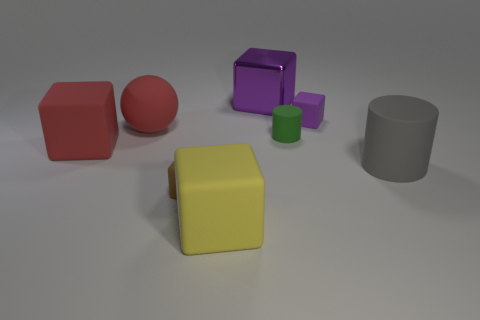Are there any gray objects that have the same material as the large yellow cube?
Offer a very short reply. Yes. There is a small thing left of the big yellow matte thing; is it the same shape as the matte thing that is behind the red ball?
Your answer should be compact. Yes. Are there any big red objects?
Make the answer very short. Yes. There is a shiny object that is the same size as the rubber sphere; what color is it?
Give a very brief answer. Purple. What number of gray matte things have the same shape as the yellow thing?
Ensure brevity in your answer.  0. Does the small brown object that is in front of the big purple object have the same material as the tiny purple object?
Ensure brevity in your answer.  Yes. What number of cylinders are big yellow objects or green matte objects?
Your response must be concise. 1. What shape is the red thing in front of the large matte object behind the matte block that is left of the small brown rubber block?
Give a very brief answer. Cube. What shape is the matte thing that is the same color as the ball?
Your answer should be compact. Cube. How many blocks are the same size as the purple metal thing?
Your answer should be very brief. 2. 